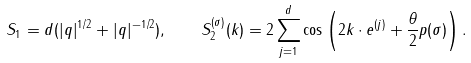Convert formula to latex. <formula><loc_0><loc_0><loc_500><loc_500>S _ { 1 } = d ( | q | ^ { 1 / 2 } + | q | ^ { - 1 / 2 } ) , \quad S _ { 2 } ^ { ( \sigma ) } ( k ) = 2 \sum _ { j = 1 } ^ { d } \cos \left ( { 2 k \cdot e ^ { ( j ) } + \frac { \theta } { 2 } p ( \sigma ) } \right ) .</formula> 